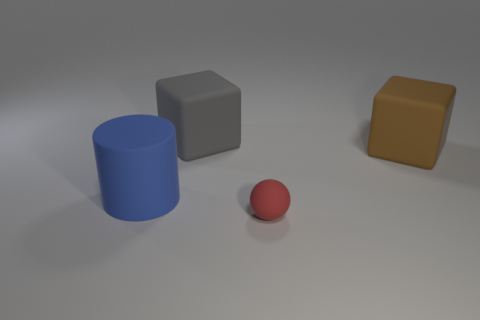How many objects are there in the image? There are four objects in the image: a blue cylinder, a grey cube, a brown cube, and a red sphere. 